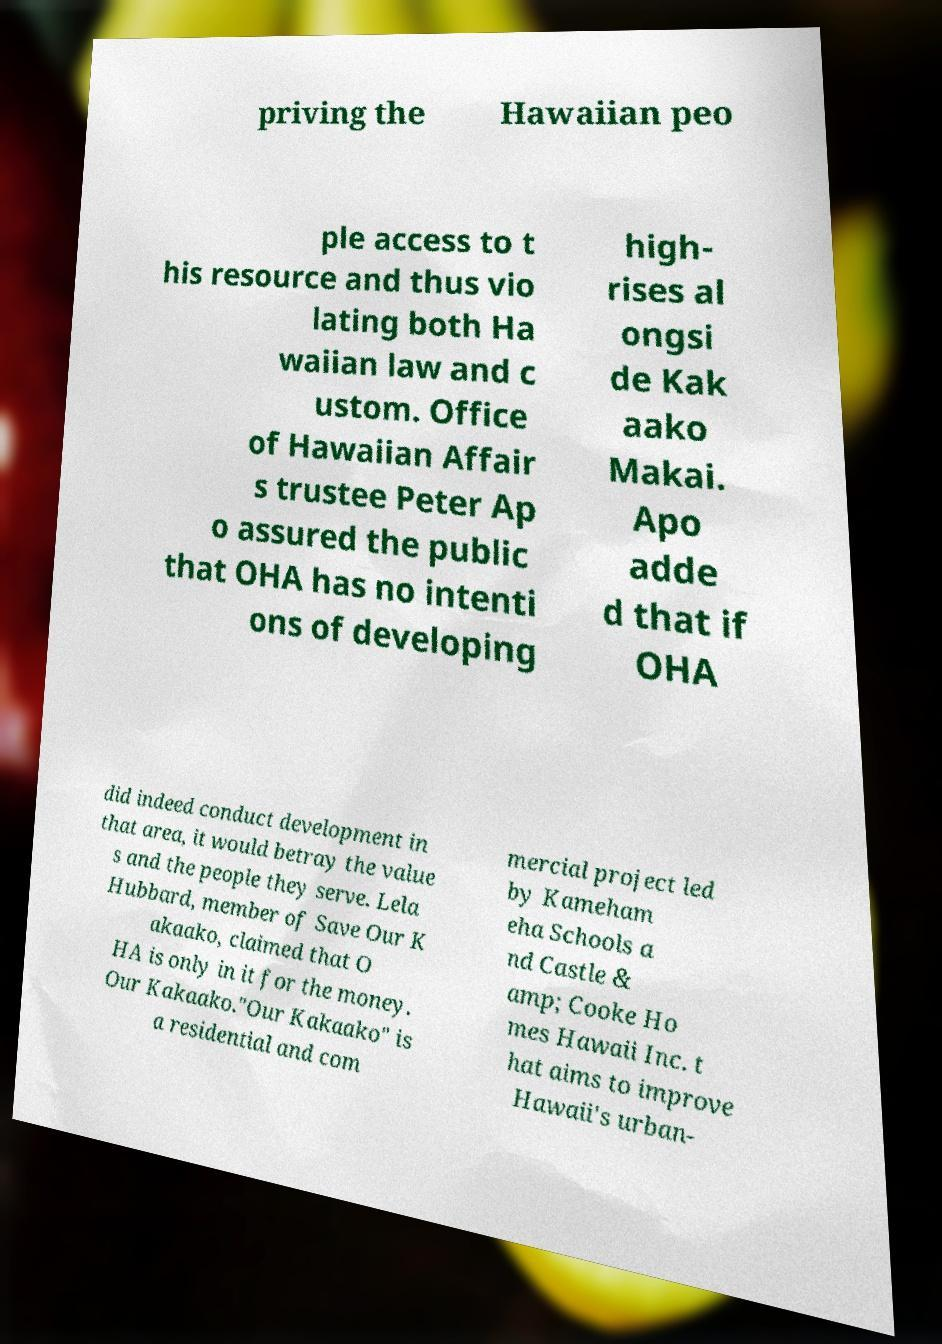Could you extract and type out the text from this image? priving the Hawaiian peo ple access to t his resource and thus vio lating both Ha waiian law and c ustom. Office of Hawaiian Affair s trustee Peter Ap o assured the public that OHA has no intenti ons of developing high- rises al ongsi de Kak aako Makai. Apo adde d that if OHA did indeed conduct development in that area, it would betray the value s and the people they serve. Lela Hubbard, member of Save Our K akaako, claimed that O HA is only in it for the money. Our Kakaako."Our Kakaako" is a residential and com mercial project led by Kameham eha Schools a nd Castle & amp; Cooke Ho mes Hawaii Inc. t hat aims to improve Hawaii's urban- 